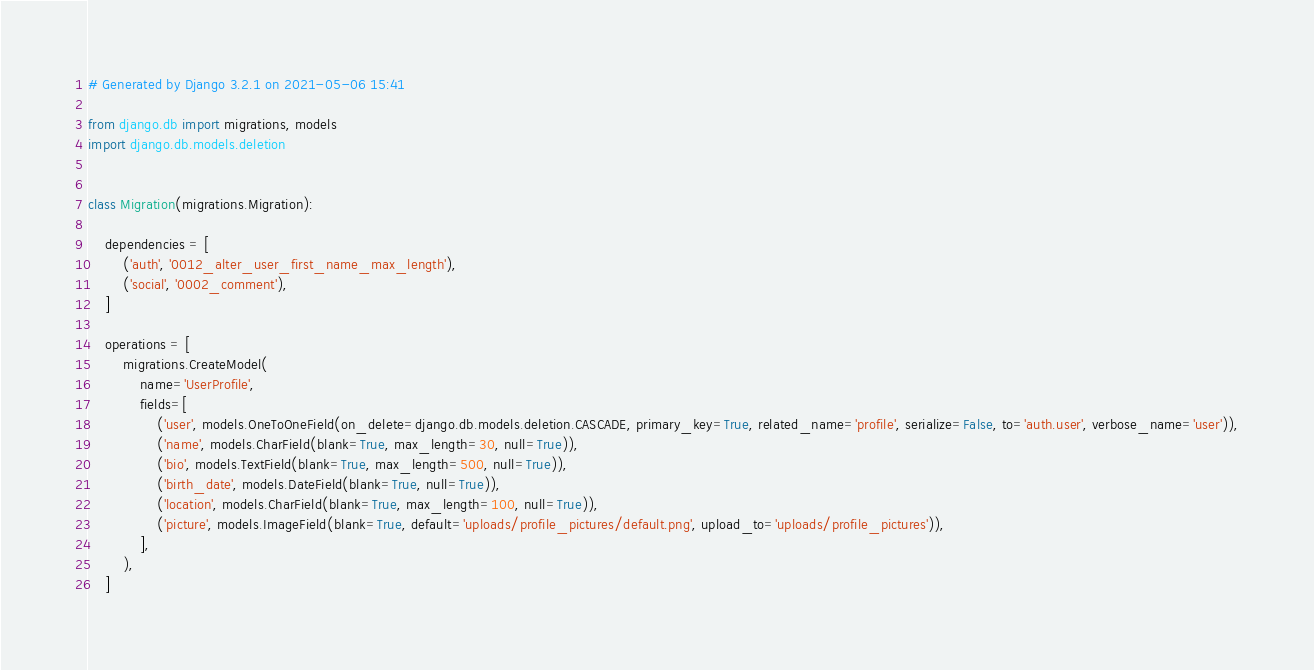Convert code to text. <code><loc_0><loc_0><loc_500><loc_500><_Python_># Generated by Django 3.2.1 on 2021-05-06 15:41

from django.db import migrations, models
import django.db.models.deletion


class Migration(migrations.Migration):

    dependencies = [
        ('auth', '0012_alter_user_first_name_max_length'),
        ('social', '0002_comment'),
    ]

    operations = [
        migrations.CreateModel(
            name='UserProfile',
            fields=[
                ('user', models.OneToOneField(on_delete=django.db.models.deletion.CASCADE, primary_key=True, related_name='profile', serialize=False, to='auth.user', verbose_name='user')),
                ('name', models.CharField(blank=True, max_length=30, null=True)),
                ('bio', models.TextField(blank=True, max_length=500, null=True)),
                ('birth_date', models.DateField(blank=True, null=True)),
                ('location', models.CharField(blank=True, max_length=100, null=True)),
                ('picture', models.ImageField(blank=True, default='uploads/profile_pictures/default.png', upload_to='uploads/profile_pictures')),
            ],
        ),
    ]
</code> 